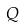<formula> <loc_0><loc_0><loc_500><loc_500>Q</formula> 